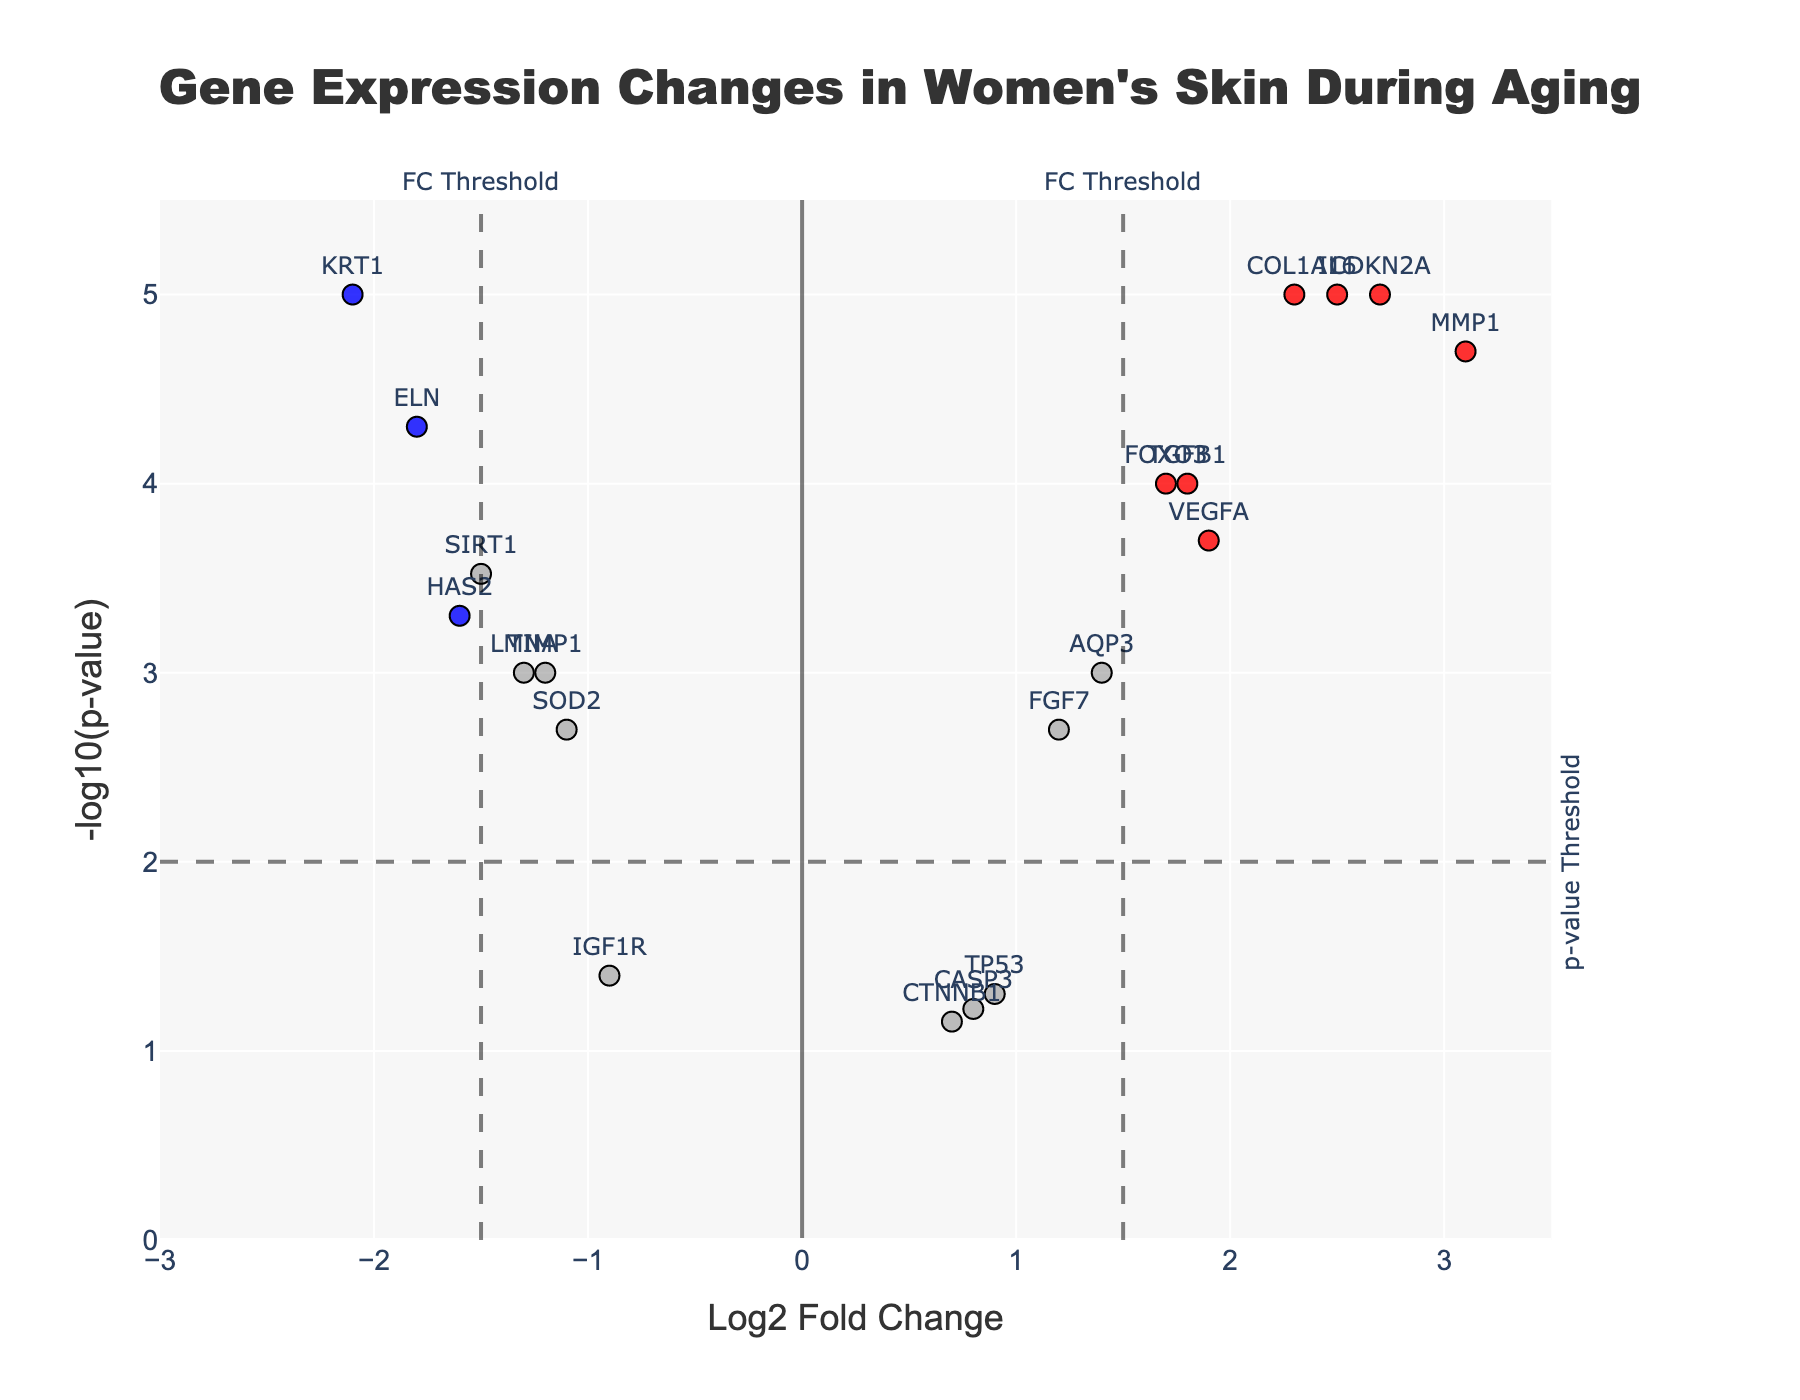How many genes are classified as "Upregulated"? Look at the category "Upregulated" in the color legend and count how many data points (red) are labeled as "Upregulated".
Answer: 7 How many genes show significant changes in expression? Check for the total number of data points marked as "Upregulated" or "Downregulated" (red and blue). These are the genes with significant expression changes.
Answer: 10 What is the significance threshold for the p-value? Locate the horizontal dashed line on the plot and look for the annotation text indicating the p-value threshold.
Answer: 0.01 Which gene has the highest positive log fold change? Find the data point furthest to the right on the x-axis. Check the label associated with it.
Answer: MMP1 Which gene has the lowest log fold change? Locate the data point furthest to the left on the x-axis. The label near this point indicates the gene with the lowest log fold change.
Answer: KRT1 Are there more upregulated or downregulated genes? Compare the number of red data points (Upregulated) against the number of blue data points (Downregulated).
Answer: Upregulated How is the gene SIRT1 categorized in the plot? Find the data point labeled "SIRT1". The color of this point will indicate its category (Upregulated, Downregulated, or Not Significant).
Answer: Downregulated What is the y-axis label of the plot? Check the text next to the y-axis which indicates its label.
Answer: -log10(p-value) What Log Fold Change value signifies the threshold for categorizing upregulated or downregulated genes? Look for the vertical dashed lines on the plot and the annotations indicating the fold change threshold.
Answer: 1.5 